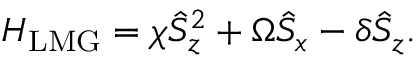Convert formula to latex. <formula><loc_0><loc_0><loc_500><loc_500>H _ { L M G } = \chi \hat { S } _ { z } ^ { 2 } + \Omega \hat { S } _ { x } - \delta \hat { S } _ { z } .</formula> 